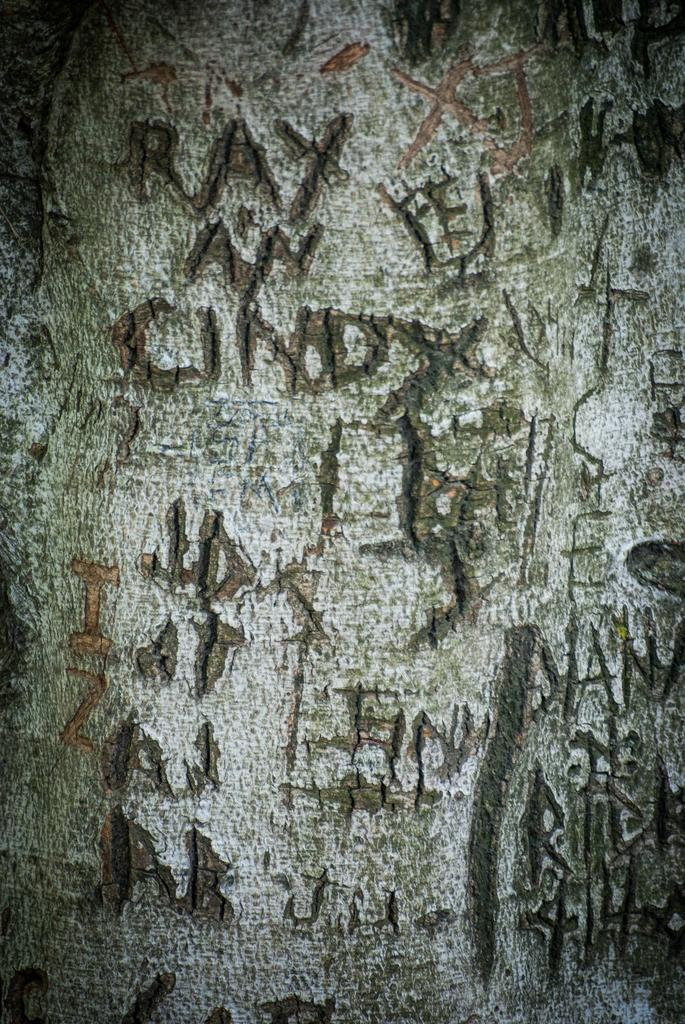What is the main object in the image with text on it? There is text on a trunk in the image. Can you describe the text on the trunk? Unfortunately, the specific text on the trunk cannot be determined from the image alone. What type of object is the trunk? The trunk appears to be a storage container or suitcase. What type of car is parked in the shade next to the trunk? There is no car present in the image; it only features a trunk with text on it. How is the glue used in the image? There is no glue present in the image. 